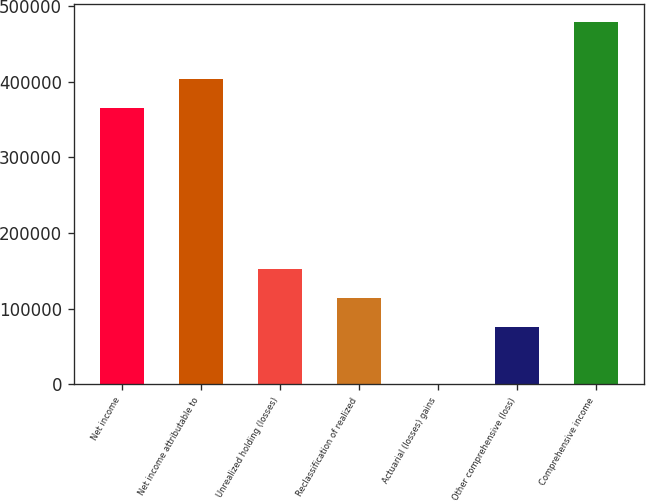Convert chart. <chart><loc_0><loc_0><loc_500><loc_500><bar_chart><fcel>Net income<fcel>Net income attributable to<fcel>Unrealized holding (losses)<fcel>Reclassification of realized<fcel>Actuarial (losses) gains<fcel>Other comprehensive (loss)<fcel>Comprehensive income<nl><fcel>365325<fcel>403275<fcel>151926<fcel>113976<fcel>127<fcel>76026.6<fcel>479174<nl></chart> 